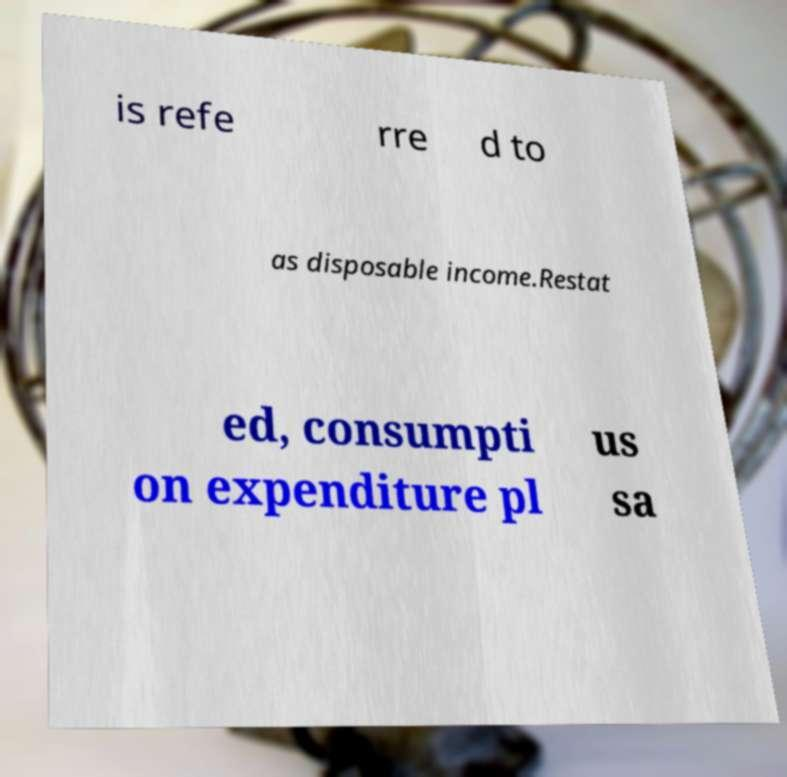Please read and relay the text visible in this image. What does it say? is refe rre d to as disposable income.Restat ed, consumpti on expenditure pl us sa 